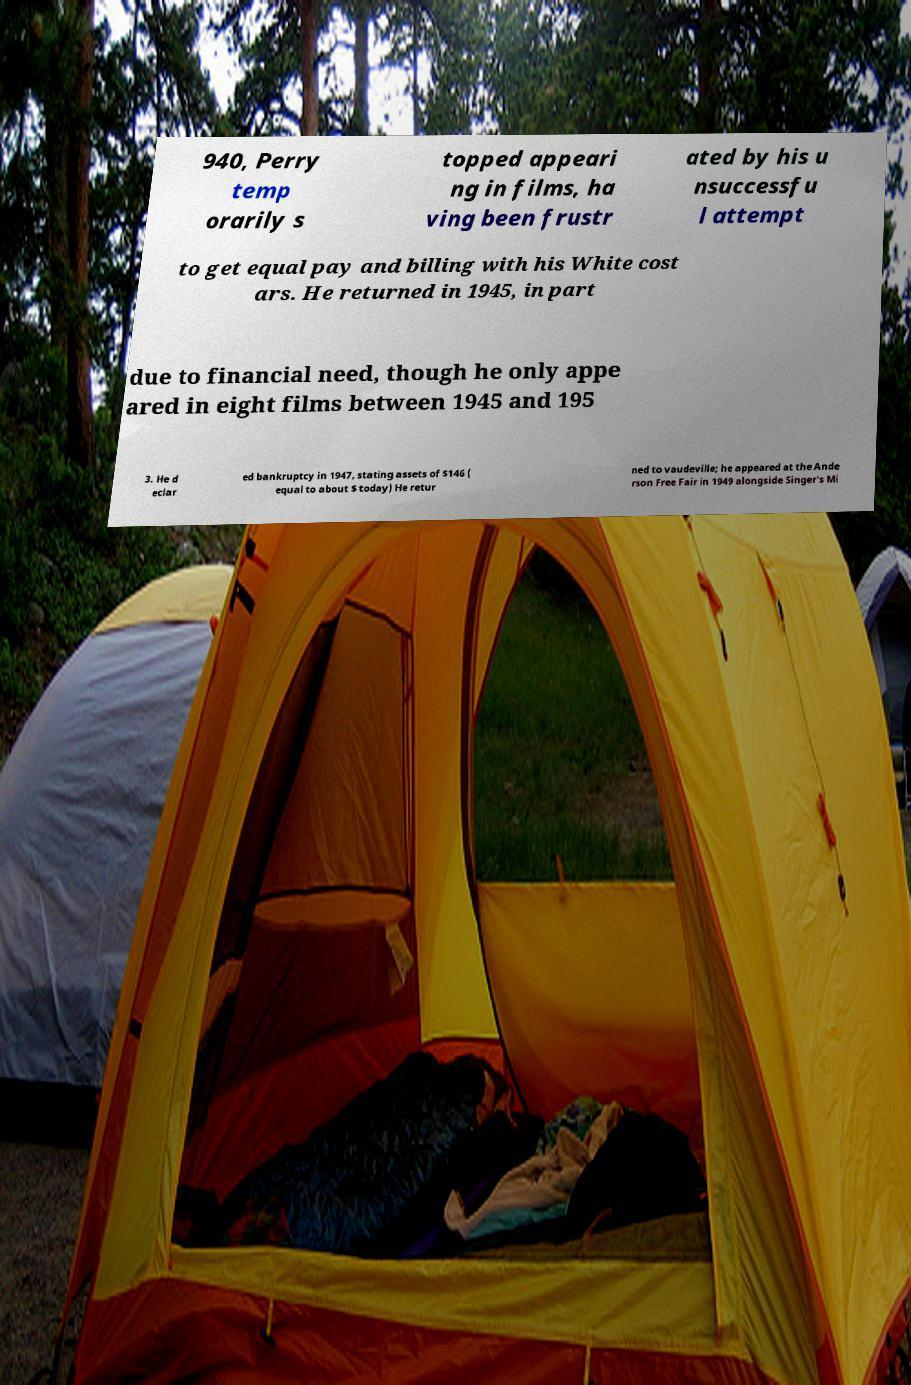Can you accurately transcribe the text from the provided image for me? 940, Perry temp orarily s topped appeari ng in films, ha ving been frustr ated by his u nsuccessfu l attempt to get equal pay and billing with his White cost ars. He returned in 1945, in part due to financial need, though he only appe ared in eight films between 1945 and 195 3. He d eclar ed bankruptcy in 1947, stating assets of $146 ( equal to about $ today) He retur ned to vaudeville; he appeared at the Ande rson Free Fair in 1949 alongside Singer's Mi 